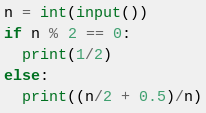Convert code to text. <code><loc_0><loc_0><loc_500><loc_500><_Python_>n = int(input())
if n % 2 == 0:
  print(1/2)
else:
  print((n/2 + 0.5)/n)
</code> 